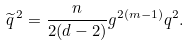Convert formula to latex. <formula><loc_0><loc_0><loc_500><loc_500>\widetilde { q } \, ^ { 2 } = { \frac { n } { 2 ( d - 2 ) } } g ^ { 2 ( m - 1 ) } q ^ { 2 } .</formula> 